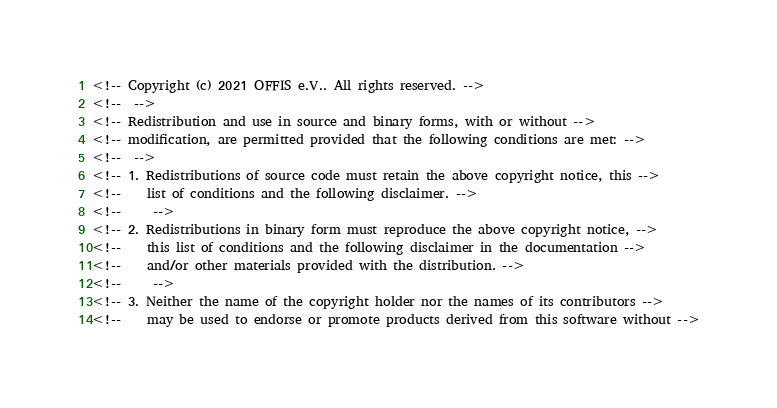<code> <loc_0><loc_0><loc_500><loc_500><_HTML_><!-- Copyright (c) 2021 OFFIS e.V.. All rights reserved. -->
<!--  -->
<!-- Redistribution and use in source and binary forms, with or without -->
<!-- modification, are permitted provided that the following conditions are met: -->
<!--  -->
<!-- 1. Redistributions of source code must retain the above copyright notice, this -->
<!--    list of conditions and the following disclaimer. -->
<!--     -->
<!-- 2. Redistributions in binary form must reproduce the above copyright notice, -->
<!--    this list of conditions and the following disclaimer in the documentation -->
<!--    and/or other materials provided with the distribution. -->
<!--     -->
<!-- 3. Neither the name of the copyright holder nor the names of its contributors -->
<!--    may be used to endorse or promote products derived from this software without --></code> 